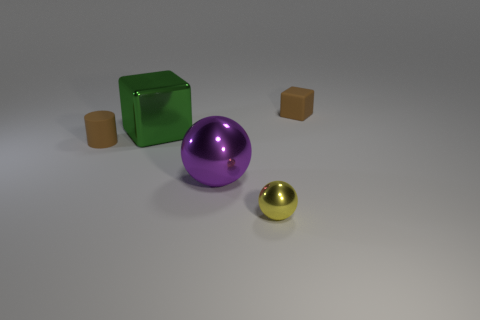Are the object that is in front of the purple metallic sphere and the cube that is left of the small yellow ball made of the same material?
Your response must be concise. Yes. How many other things are there of the same size as the brown matte cylinder?
Provide a short and direct response. 2. What number of objects are brown cylinders or objects on the right side of the cylinder?
Your answer should be very brief. 5. Are there an equal number of shiny balls behind the tiny brown matte cube and cyan matte things?
Give a very brief answer. Yes. The green thing that is the same material as the tiny yellow sphere is what shape?
Keep it short and to the point. Cube. Are there any large objects that have the same color as the matte block?
Offer a very short reply. No. What number of matte things are either tiny cubes or small brown things?
Your answer should be compact. 2. There is a small brown rubber object that is left of the tiny brown block; what number of tiny yellow balls are on the right side of it?
Offer a very short reply. 1. What number of cylinders have the same material as the large purple object?
Give a very brief answer. 0. What number of small things are gray things or cubes?
Provide a short and direct response. 1. 